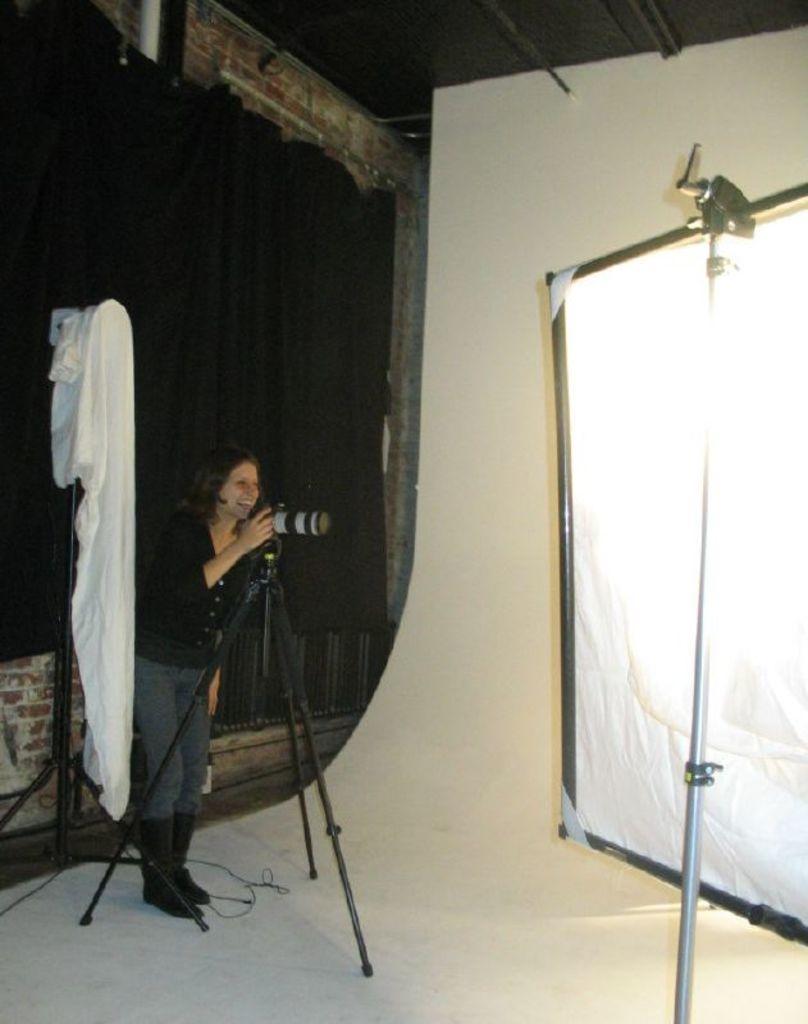Describe this image in one or two sentences. There is one person standing on the left side of this image is holding a camera. There is one white color cloth is on the left side to this person. There is a black color curtain on the left side of this image and there is a white color curtain on the right side of this image. 